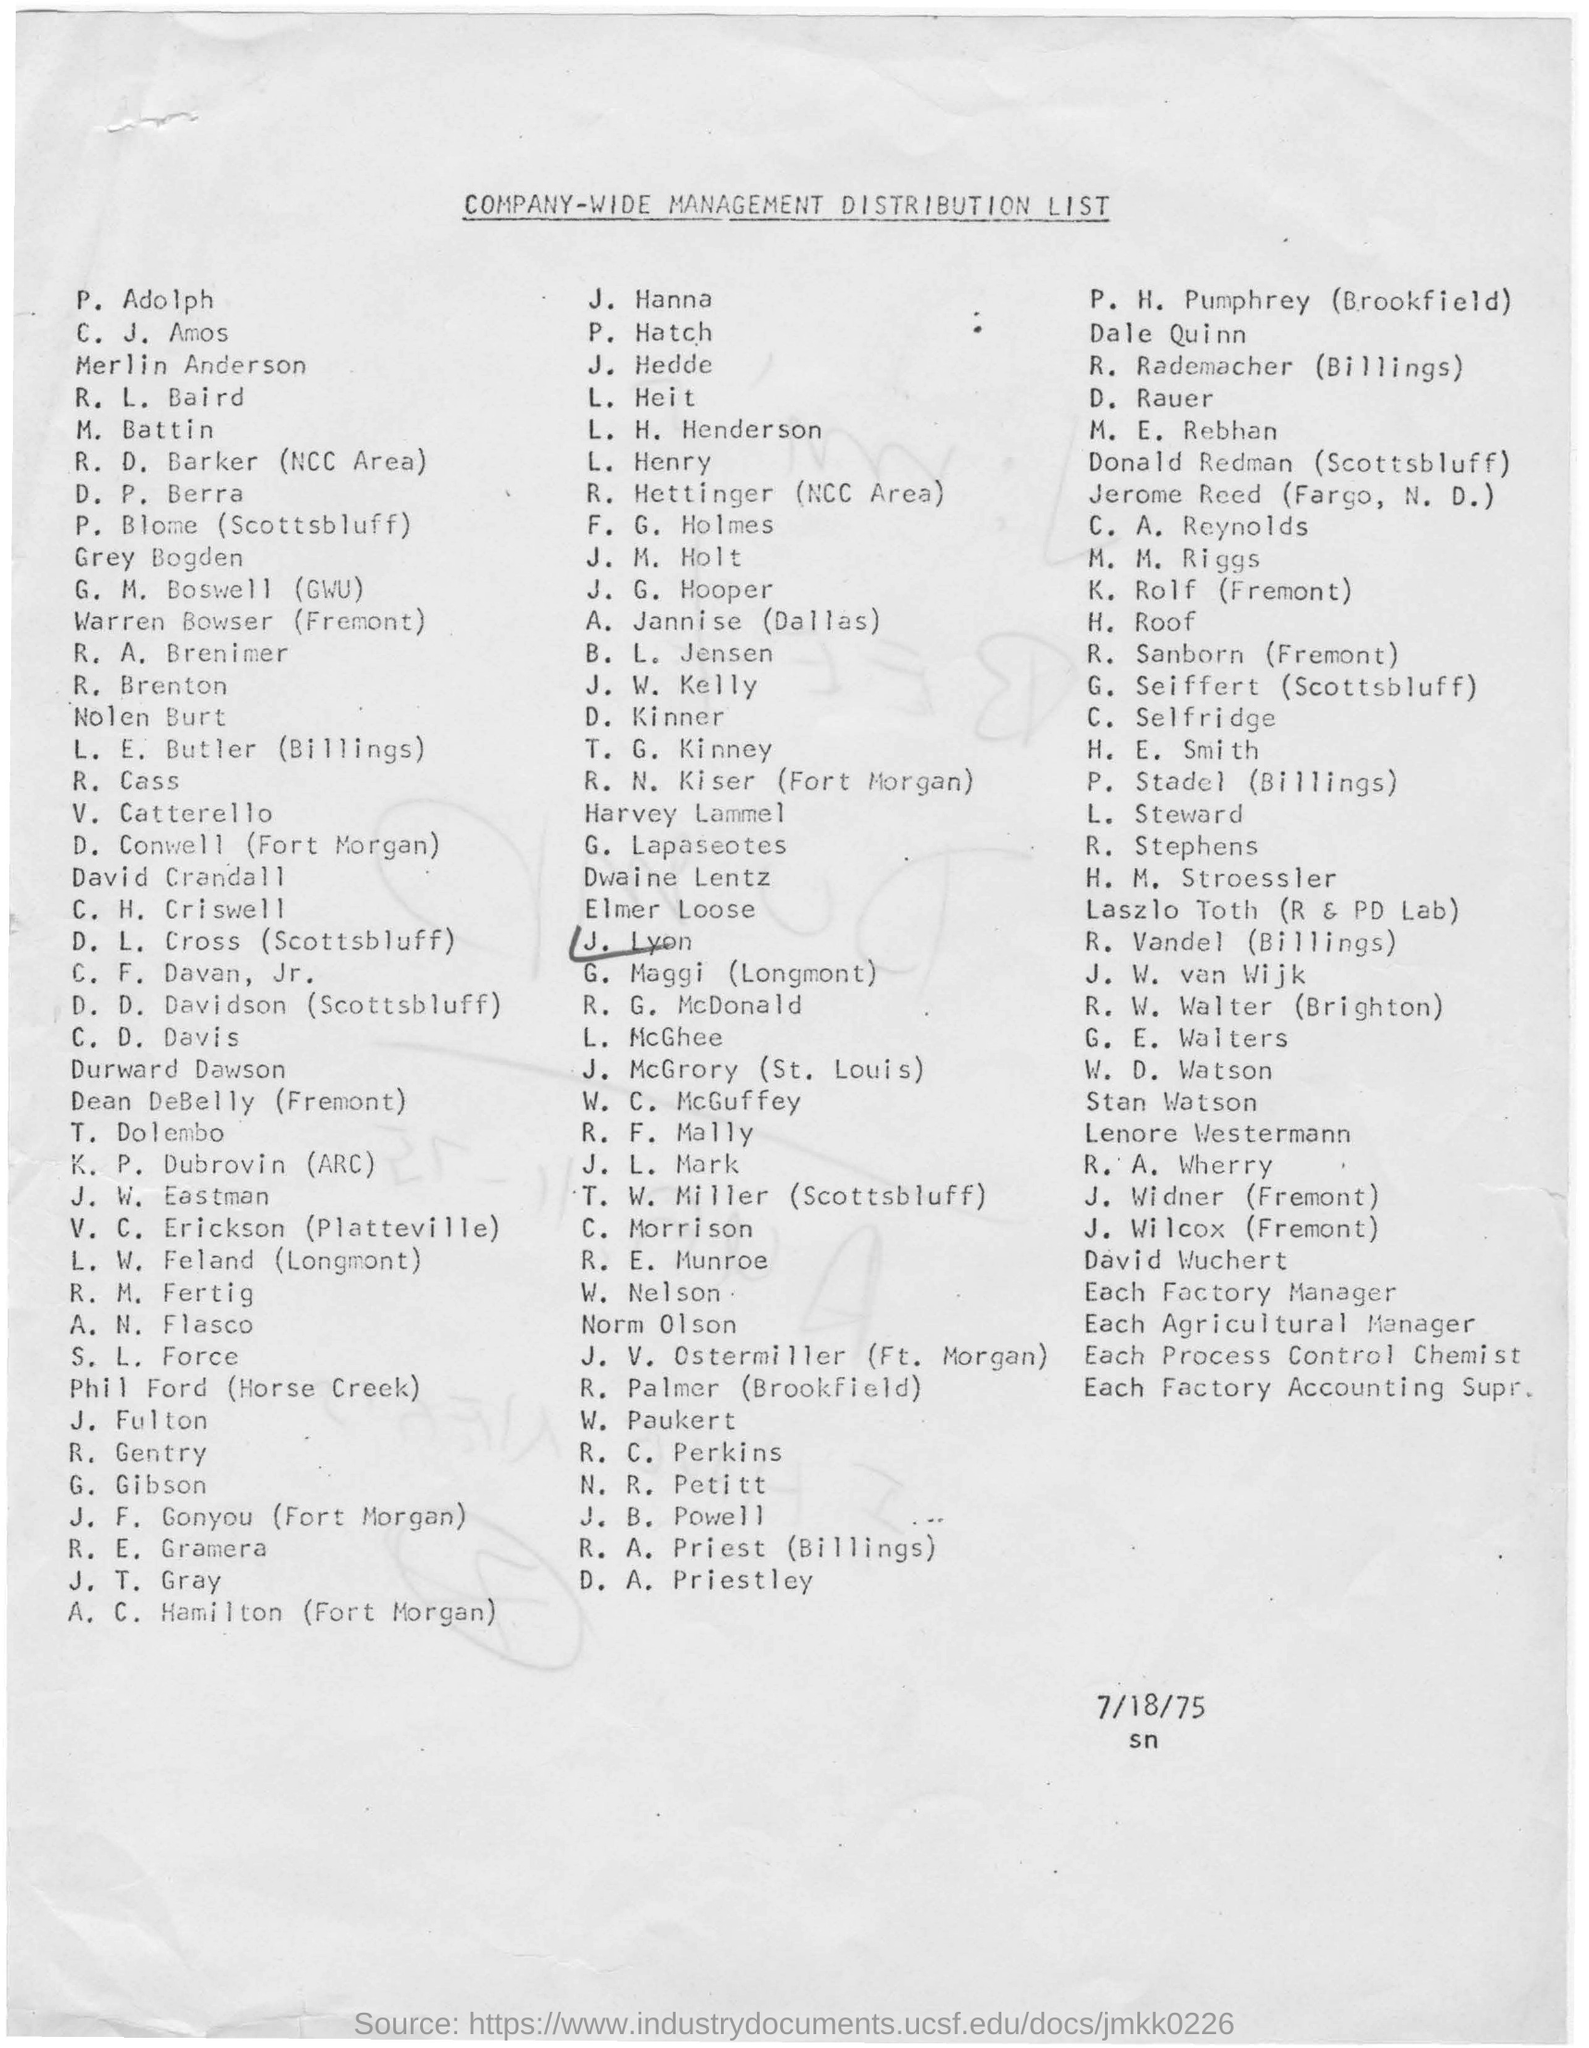What is date mentioned below the document
Your answer should be compact. 7/18/75. What is the Head line of the document
Offer a terse response. Company-wide Management Distribution List. Whose name is ticked using a pen in this list?
Offer a terse response. J. Lyon. 